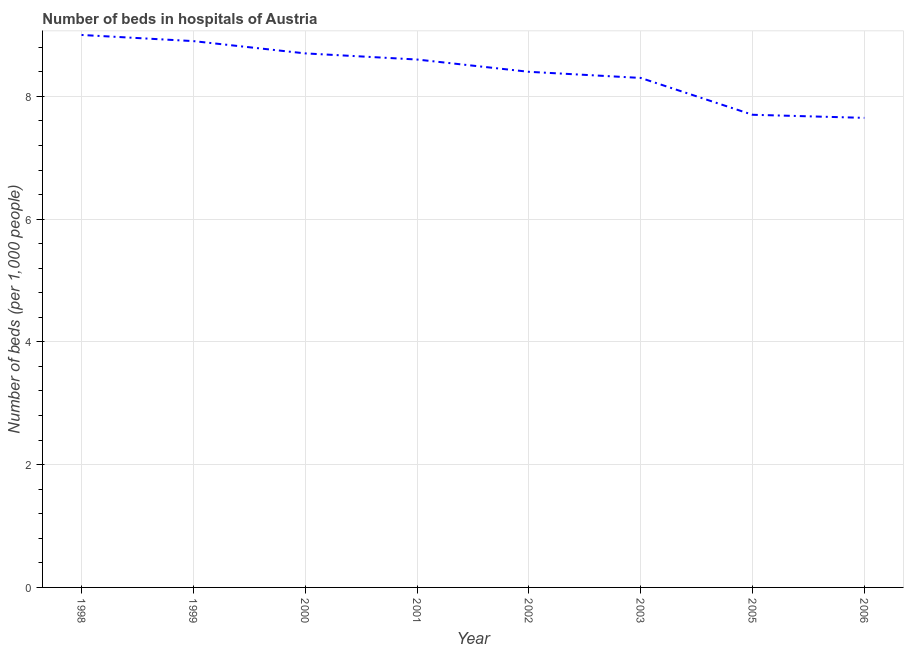Across all years, what is the maximum number of hospital beds?
Keep it short and to the point. 9. Across all years, what is the minimum number of hospital beds?
Give a very brief answer. 7.65. In which year was the number of hospital beds maximum?
Your answer should be compact. 1998. What is the sum of the number of hospital beds?
Your response must be concise. 67.25. What is the difference between the number of hospital beds in 1999 and 2003?
Give a very brief answer. 0.6. What is the average number of hospital beds per year?
Provide a short and direct response. 8.41. In how many years, is the number of hospital beds greater than 6.4 %?
Provide a short and direct response. 8. Do a majority of the years between 1998 and 1999 (inclusive) have number of hospital beds greater than 6.4 %?
Your response must be concise. Yes. What is the ratio of the number of hospital beds in 2002 to that in 2006?
Ensure brevity in your answer.  1.1. Is the number of hospital beds in 2001 less than that in 2006?
Make the answer very short. No. What is the difference between the highest and the second highest number of hospital beds?
Offer a terse response. 0.1. Is the sum of the number of hospital beds in 1998 and 2006 greater than the maximum number of hospital beds across all years?
Your answer should be compact. Yes. What is the difference between the highest and the lowest number of hospital beds?
Your answer should be compact. 1.35. Does the number of hospital beds monotonically increase over the years?
Give a very brief answer. No. How many lines are there?
Give a very brief answer. 1. What is the difference between two consecutive major ticks on the Y-axis?
Offer a very short reply. 2. Does the graph contain any zero values?
Keep it short and to the point. No. What is the title of the graph?
Offer a terse response. Number of beds in hospitals of Austria. What is the label or title of the Y-axis?
Give a very brief answer. Number of beds (per 1,0 people). What is the Number of beds (per 1,000 people) of 1999?
Provide a succinct answer. 8.9. What is the Number of beds (per 1,000 people) of 2000?
Keep it short and to the point. 8.7. What is the Number of beds (per 1,000 people) of 2001?
Provide a succinct answer. 8.6. What is the Number of beds (per 1,000 people) of 2002?
Provide a succinct answer. 8.4. What is the Number of beds (per 1,000 people) in 2003?
Your answer should be very brief. 8.3. What is the Number of beds (per 1,000 people) of 2006?
Provide a succinct answer. 7.65. What is the difference between the Number of beds (per 1,000 people) in 1998 and 2001?
Offer a very short reply. 0.4. What is the difference between the Number of beds (per 1,000 people) in 1998 and 2002?
Make the answer very short. 0.6. What is the difference between the Number of beds (per 1,000 people) in 1998 and 2006?
Make the answer very short. 1.35. What is the difference between the Number of beds (per 1,000 people) in 1999 and 2000?
Make the answer very short. 0.2. What is the difference between the Number of beds (per 1,000 people) in 1999 and 2002?
Keep it short and to the point. 0.5. What is the difference between the Number of beds (per 1,000 people) in 1999 and 2006?
Make the answer very short. 1.25. What is the difference between the Number of beds (per 1,000 people) in 2000 and 2001?
Provide a short and direct response. 0.1. What is the difference between the Number of beds (per 1,000 people) in 2000 and 2003?
Provide a succinct answer. 0.4. What is the difference between the Number of beds (per 1,000 people) in 2000 and 2006?
Your answer should be compact. 1.05. What is the difference between the Number of beds (per 1,000 people) in 2001 and 2006?
Provide a short and direct response. 0.95. What is the difference between the Number of beds (per 1,000 people) in 2002 and 2003?
Provide a short and direct response. 0.1. What is the difference between the Number of beds (per 1,000 people) in 2002 and 2006?
Ensure brevity in your answer.  0.75. What is the difference between the Number of beds (per 1,000 people) in 2003 and 2005?
Keep it short and to the point. 0.6. What is the difference between the Number of beds (per 1,000 people) in 2003 and 2006?
Keep it short and to the point. 0.65. What is the difference between the Number of beds (per 1,000 people) in 2005 and 2006?
Make the answer very short. 0.05. What is the ratio of the Number of beds (per 1,000 people) in 1998 to that in 1999?
Make the answer very short. 1.01. What is the ratio of the Number of beds (per 1,000 people) in 1998 to that in 2000?
Offer a terse response. 1.03. What is the ratio of the Number of beds (per 1,000 people) in 1998 to that in 2001?
Make the answer very short. 1.05. What is the ratio of the Number of beds (per 1,000 people) in 1998 to that in 2002?
Provide a short and direct response. 1.07. What is the ratio of the Number of beds (per 1,000 people) in 1998 to that in 2003?
Offer a very short reply. 1.08. What is the ratio of the Number of beds (per 1,000 people) in 1998 to that in 2005?
Your response must be concise. 1.17. What is the ratio of the Number of beds (per 1,000 people) in 1998 to that in 2006?
Provide a succinct answer. 1.18. What is the ratio of the Number of beds (per 1,000 people) in 1999 to that in 2001?
Your response must be concise. 1.03. What is the ratio of the Number of beds (per 1,000 people) in 1999 to that in 2002?
Offer a terse response. 1.06. What is the ratio of the Number of beds (per 1,000 people) in 1999 to that in 2003?
Your answer should be compact. 1.07. What is the ratio of the Number of beds (per 1,000 people) in 1999 to that in 2005?
Keep it short and to the point. 1.16. What is the ratio of the Number of beds (per 1,000 people) in 1999 to that in 2006?
Ensure brevity in your answer.  1.16. What is the ratio of the Number of beds (per 1,000 people) in 2000 to that in 2001?
Provide a succinct answer. 1.01. What is the ratio of the Number of beds (per 1,000 people) in 2000 to that in 2002?
Your response must be concise. 1.04. What is the ratio of the Number of beds (per 1,000 people) in 2000 to that in 2003?
Make the answer very short. 1.05. What is the ratio of the Number of beds (per 1,000 people) in 2000 to that in 2005?
Keep it short and to the point. 1.13. What is the ratio of the Number of beds (per 1,000 people) in 2000 to that in 2006?
Offer a very short reply. 1.14. What is the ratio of the Number of beds (per 1,000 people) in 2001 to that in 2002?
Offer a very short reply. 1.02. What is the ratio of the Number of beds (per 1,000 people) in 2001 to that in 2003?
Provide a short and direct response. 1.04. What is the ratio of the Number of beds (per 1,000 people) in 2001 to that in 2005?
Provide a short and direct response. 1.12. What is the ratio of the Number of beds (per 1,000 people) in 2001 to that in 2006?
Your answer should be very brief. 1.12. What is the ratio of the Number of beds (per 1,000 people) in 2002 to that in 2003?
Offer a terse response. 1.01. What is the ratio of the Number of beds (per 1,000 people) in 2002 to that in 2005?
Provide a succinct answer. 1.09. What is the ratio of the Number of beds (per 1,000 people) in 2002 to that in 2006?
Offer a terse response. 1.1. What is the ratio of the Number of beds (per 1,000 people) in 2003 to that in 2005?
Provide a succinct answer. 1.08. What is the ratio of the Number of beds (per 1,000 people) in 2003 to that in 2006?
Give a very brief answer. 1.08. 